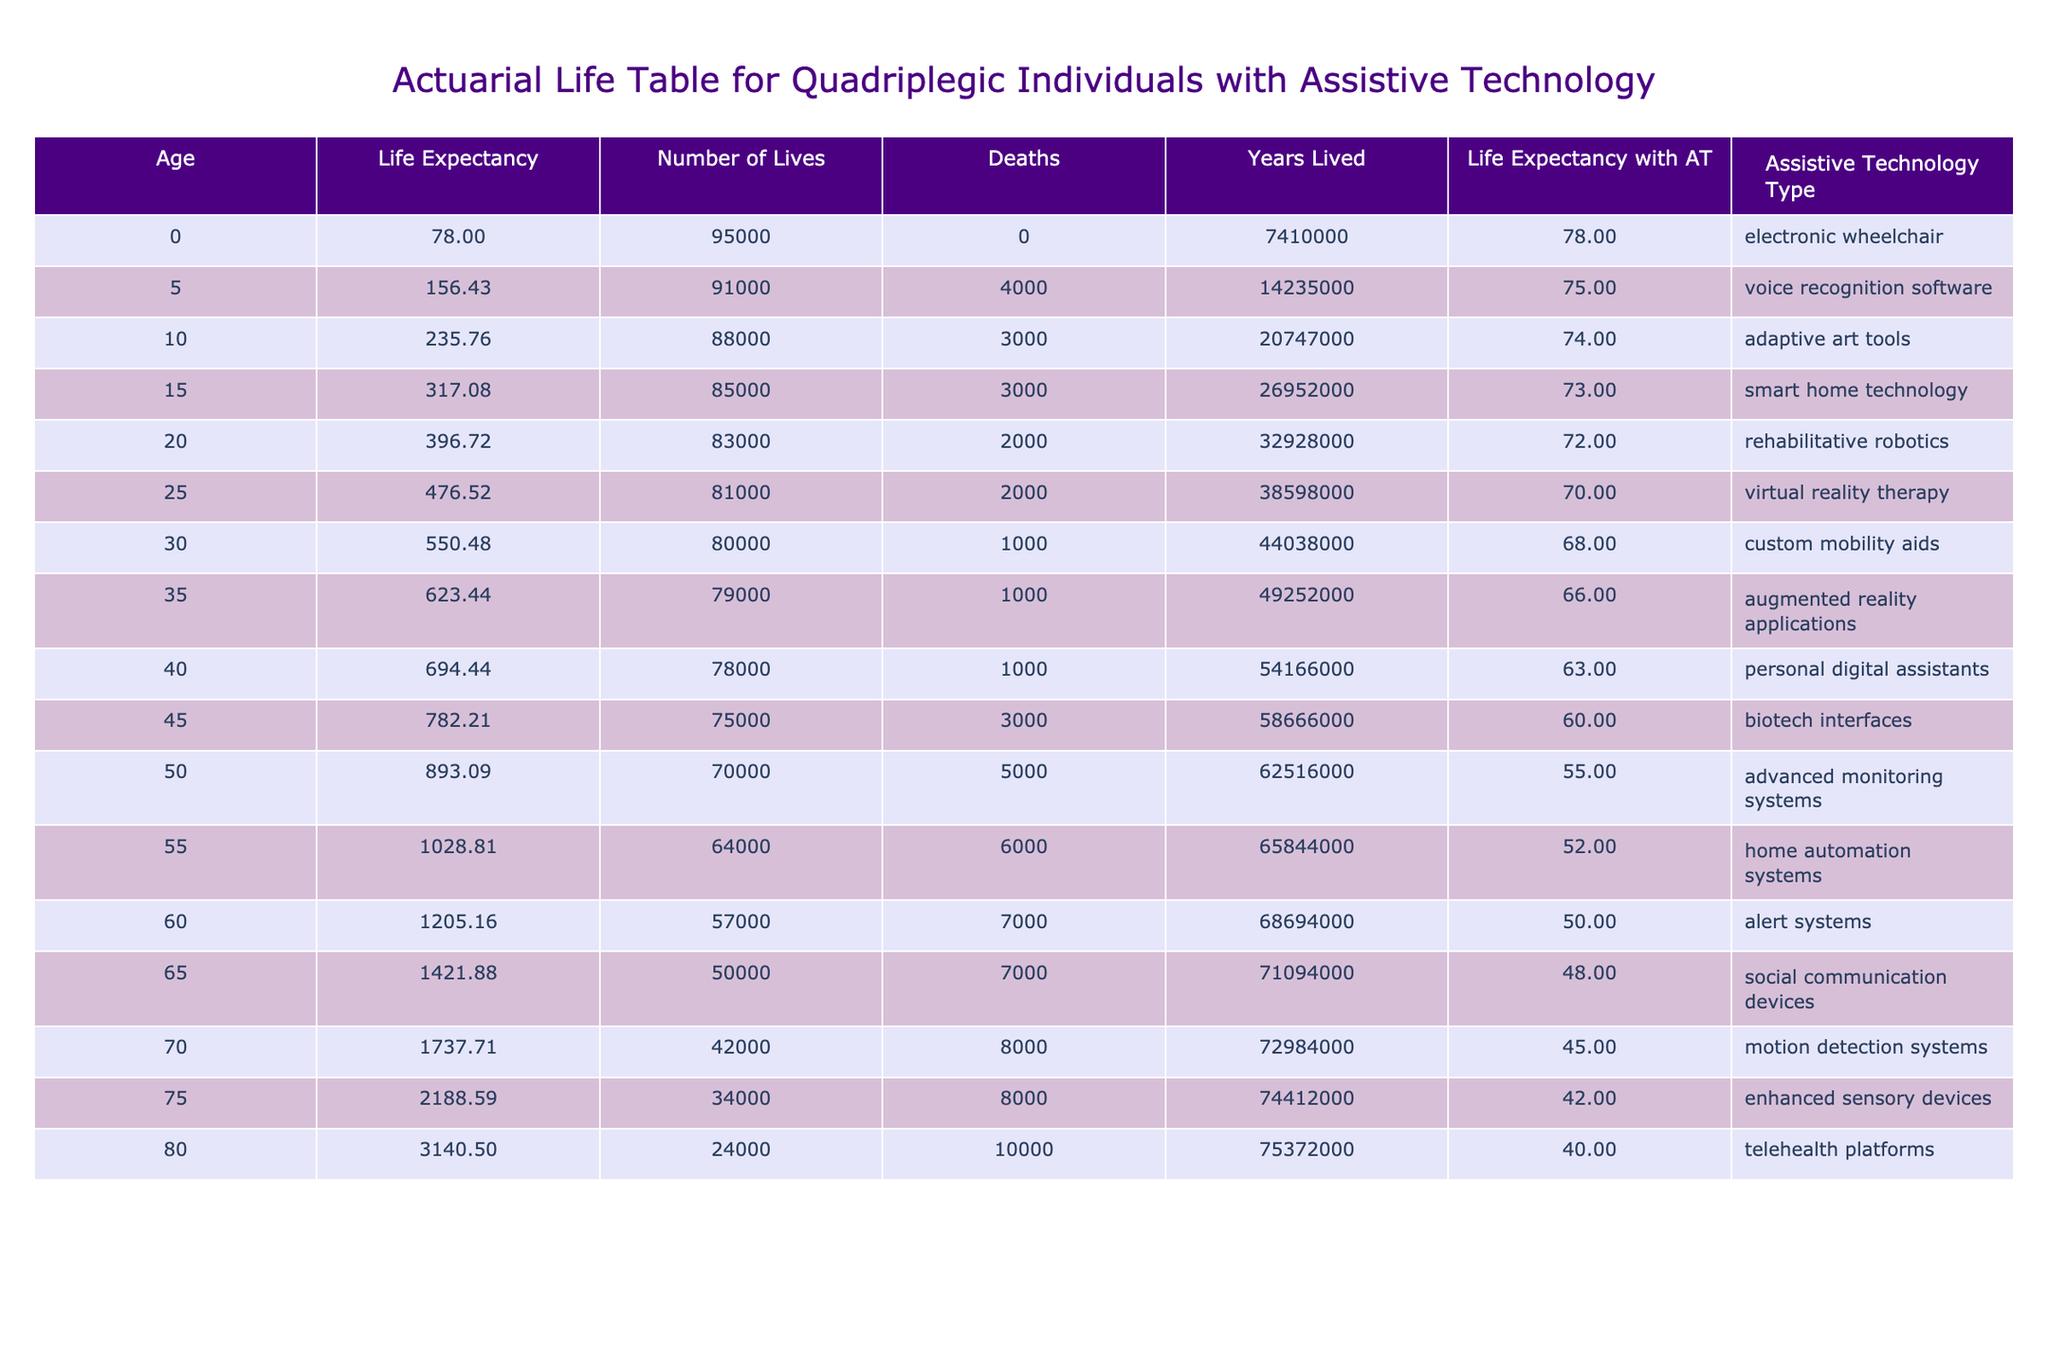What is the life expectancy of a 60-year-old individual with quadriplegia using assistive technology? From the table, we can directly find that the life expectancy for a 60-year-old individual with quadriplegia using assistive technology is listed as 50 years.
Answer: 50 What assistive technology type is associated with the highest reduction in life expectancy? By analyzing the "Reduction in Life Expectancy" column, we find that "telehealth platforms" have the highest reduction of 10 years, more than any other type.
Answer: Telehealth platforms At what age do individuals with quadriplegia start to have a life expectancy below 50 years with assistive technology? From the data, we see the life expectancy drops below 50 between the ages of 55 and 60. The first occurrence is at age 55 when the life expectancy is 52 years.
Answer: 55 What is the average life expectancy of individuals using "smart home technology" and "rehabilitative robotics"? The life expectancies associated with "smart home technology" (73 years) and "rehabilitative robotics" (72 years) are summed: 73 + 72 = 145 years, then divided by 2 for the average: 145 / 2 = 72.5 years.
Answer: 72.5 Is the life expectancy for a 15-year-old with quadriplegia higher than that for a 35-year-old with quadriplegia? Checking the values, a 15-year-old has a life expectancy of 73 years, while a 35-year-old has an expectancy of 66. Since 73 is greater than 66, the statement is true.
Answer: Yes If someone experiences a reduction in life expectancy of 5 years, what age are they likely to be? Looking at the "Reduction in Life Expectancy" column, we see multiple ages such as 0, 50, and 55 correspond to a 5-year reduction. Therefore, one can be either 0 years, 50 years, or 55 years old.
Answer: 0, 50, or 55 What is the total reduction in life expectancy for all ages listed in the table? Summing all the reductions (5 + 4 + 3 + 3 + 2 + 2 + 1 + 1 + 1 + 3 + 5 + 6 + 7 + 7 + 8 + 8 + 10) gives a total reduction of 65 years across the table.
Answer: 65 At what age does the reduction in life expectancy begin to show a noticeable increase, specifically moving from a reduction of less than 5 to equal or above it? The data indicates that the reduction is under 5 years until age 50, where the reduction is exactly 5 years. Therefore, the noticeable increase starts at age 50.
Answer: 50 Which assistive technology type is correlated with the oldest life expectancy listed in the table? The highest life expectancy reported is 78 years at age 0 with "electronic wheelchair" as the assistive technology type.
Answer: Electronic wheelchair 